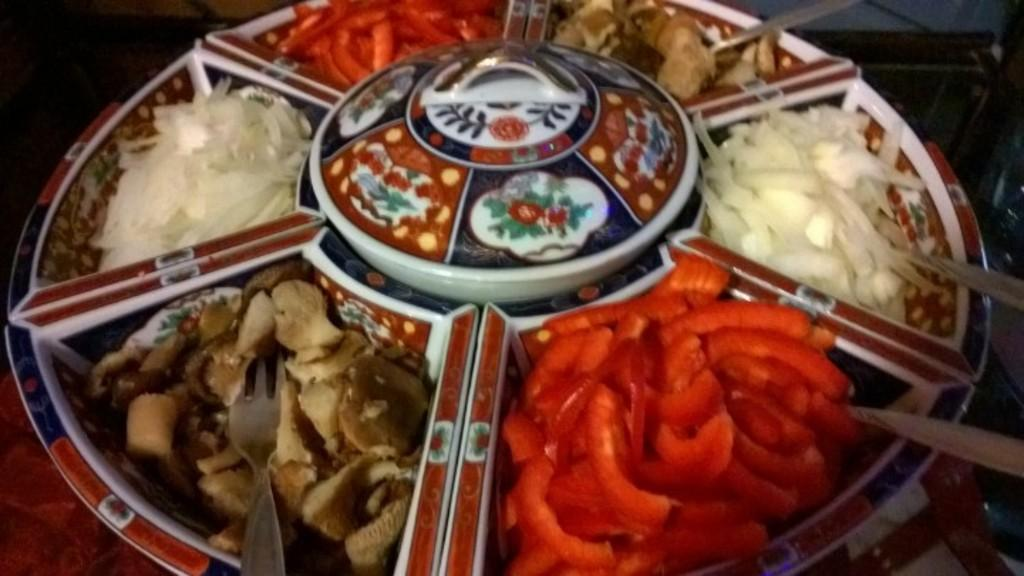What is the main subject of the image? The main subject of the image is food items in the center. What utensils are present with the food? Spoons are present on the plate, and a fork is also on the plate. What is the location of the plate in the image? The plate is on a table at the bottom of the image. Can you hear the sound of someone laughing in the image? There is no sound or indication of laughter in the image; it is a still image of food items, spoons, a fork, and a table. 